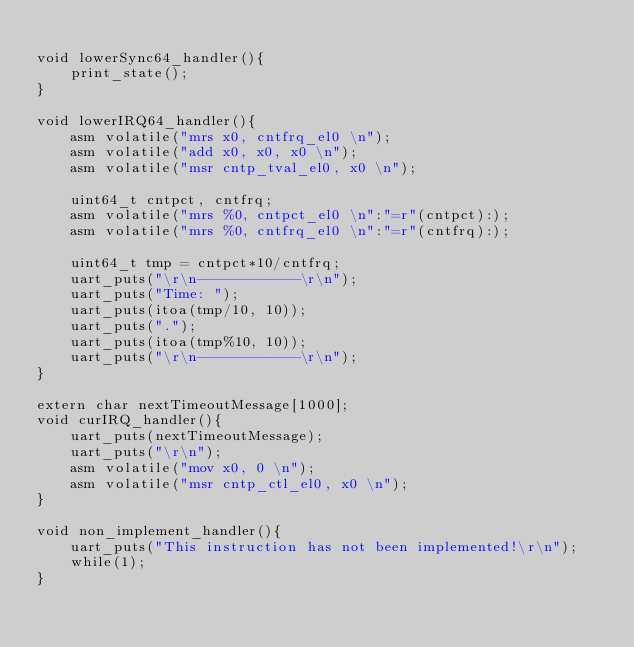Convert code to text. <code><loc_0><loc_0><loc_500><loc_500><_C_>
void lowerSync64_handler(){
    print_state();
}

void lowerIRQ64_handler(){
    asm volatile("mrs x0, cntfrq_el0 \n");
    asm volatile("add x0, x0, x0 \n");
    asm volatile("msr cntp_tval_el0, x0 \n");
    
    uint64_t cntpct, cntfrq;
    asm volatile("mrs %0, cntpct_el0 \n":"=r"(cntpct):);
    asm volatile("mrs %0, cntfrq_el0 \n":"=r"(cntfrq):);

    uint64_t tmp = cntpct*10/cntfrq;
    uart_puts("\r\n------------\r\n");
    uart_puts("Time: ");
    uart_puts(itoa(tmp/10, 10));
    uart_puts(".");
    uart_puts(itoa(tmp%10, 10));
    uart_puts("\r\n------------\r\n");
}

extern char nextTimeoutMessage[1000];
void curIRQ_handler(){
    uart_puts(nextTimeoutMessage);
    uart_puts("\r\n");
    asm volatile("mov x0, 0 \n");
    asm volatile("msr cntp_ctl_el0, x0 \n");
}

void non_implement_handler(){
    uart_puts("This instruction has not been implemented!\r\n");
    while(1);
}</code> 